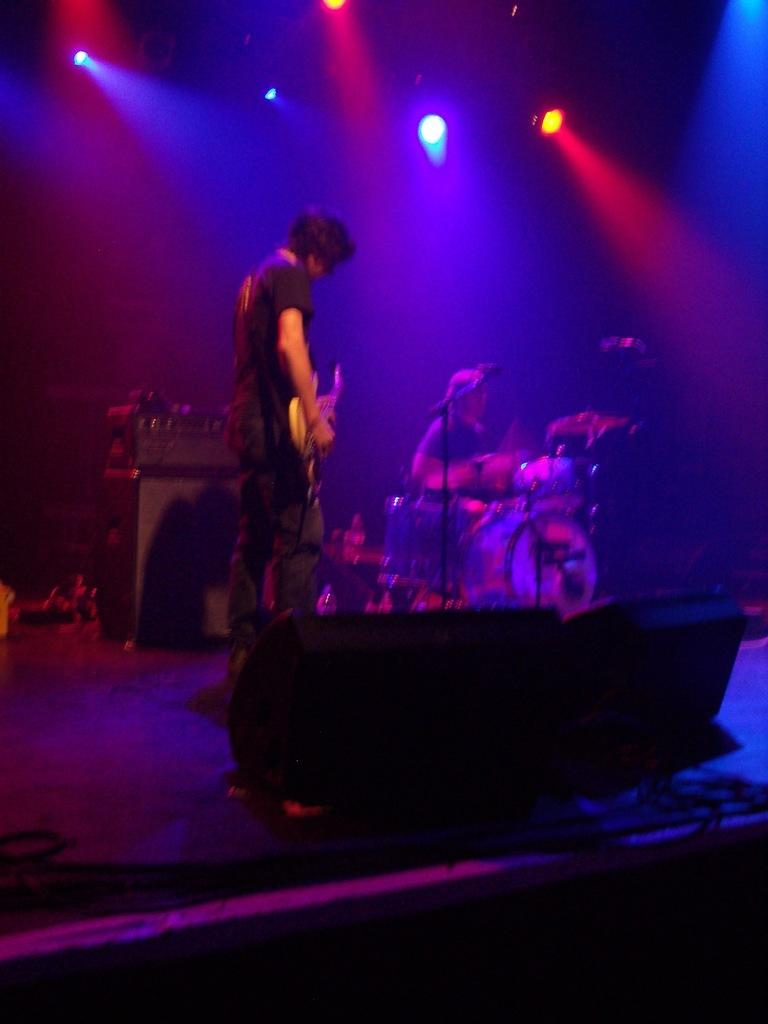How many people are in the image? There are two men in the image. What are the men doing in the image? The men are playing musical instruments. Can you identify the instruments they are playing? One of the instruments is a guitar, and the other is a drum. Where are the men performing? They are performing on a stage. What can be seen in the background of the image? There are lights visible in the background. Are there any fairies playing instruments alongside the men in the image? No, there are no fairies present in the image. Can you tell me how many basins are visible on the stage? There are no basins visible on the stage in the image. 